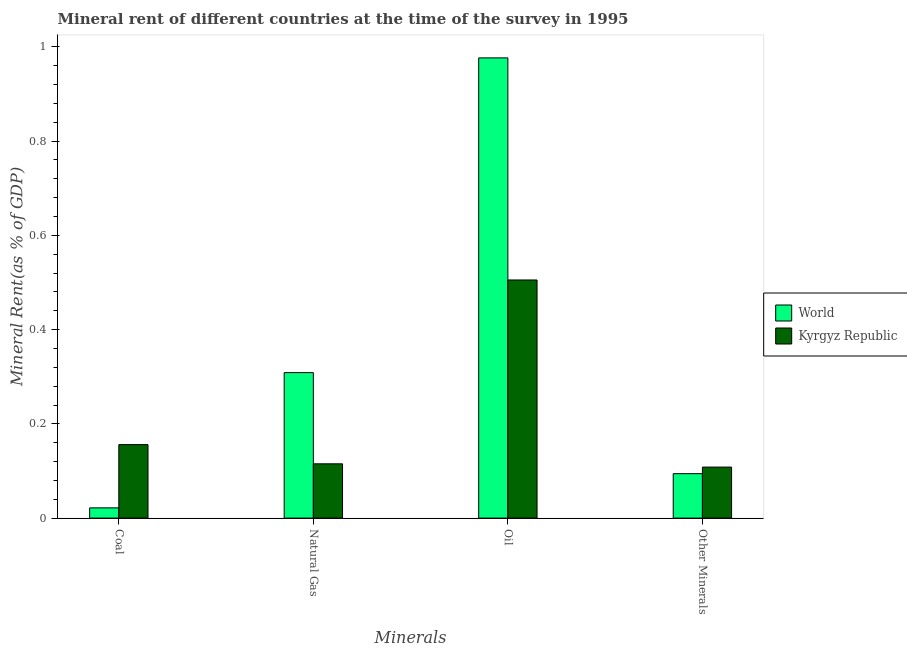How many different coloured bars are there?
Provide a succinct answer. 2. How many groups of bars are there?
Provide a succinct answer. 4. Are the number of bars per tick equal to the number of legend labels?
Make the answer very short. Yes. How many bars are there on the 3rd tick from the left?
Offer a terse response. 2. What is the label of the 1st group of bars from the left?
Provide a succinct answer. Coal. What is the  rent of other minerals in Kyrgyz Republic?
Offer a very short reply. 0.11. Across all countries, what is the maximum coal rent?
Offer a terse response. 0.16. Across all countries, what is the minimum natural gas rent?
Your response must be concise. 0.12. In which country was the coal rent maximum?
Keep it short and to the point. Kyrgyz Republic. In which country was the oil rent minimum?
Offer a very short reply. Kyrgyz Republic. What is the total natural gas rent in the graph?
Provide a short and direct response. 0.42. What is the difference between the natural gas rent in World and that in Kyrgyz Republic?
Provide a short and direct response. 0.19. What is the difference between the oil rent in Kyrgyz Republic and the  rent of other minerals in World?
Ensure brevity in your answer.  0.41. What is the average natural gas rent per country?
Provide a succinct answer. 0.21. What is the difference between the  rent of other minerals and natural gas rent in World?
Offer a very short reply. -0.21. What is the ratio of the oil rent in Kyrgyz Republic to that in World?
Your response must be concise. 0.52. What is the difference between the highest and the second highest oil rent?
Your answer should be compact. 0.47. What is the difference between the highest and the lowest natural gas rent?
Offer a terse response. 0.19. Is it the case that in every country, the sum of the coal rent and oil rent is greater than the sum of natural gas rent and  rent of other minerals?
Give a very brief answer. No. What does the 1st bar from the left in Other Minerals represents?
Offer a very short reply. World. What does the 2nd bar from the right in Coal represents?
Ensure brevity in your answer.  World. Are all the bars in the graph horizontal?
Offer a very short reply. No. What is the difference between two consecutive major ticks on the Y-axis?
Your answer should be compact. 0.2. How many legend labels are there?
Make the answer very short. 2. What is the title of the graph?
Your answer should be very brief. Mineral rent of different countries at the time of the survey in 1995. Does "Tajikistan" appear as one of the legend labels in the graph?
Offer a terse response. No. What is the label or title of the X-axis?
Provide a short and direct response. Minerals. What is the label or title of the Y-axis?
Provide a succinct answer. Mineral Rent(as % of GDP). What is the Mineral Rent(as % of GDP) of World in Coal?
Offer a very short reply. 0.02. What is the Mineral Rent(as % of GDP) of Kyrgyz Republic in Coal?
Provide a short and direct response. 0.16. What is the Mineral Rent(as % of GDP) of World in Natural Gas?
Your response must be concise. 0.31. What is the Mineral Rent(as % of GDP) of Kyrgyz Republic in Natural Gas?
Give a very brief answer. 0.12. What is the Mineral Rent(as % of GDP) in World in Oil?
Your response must be concise. 0.98. What is the Mineral Rent(as % of GDP) in Kyrgyz Republic in Oil?
Provide a succinct answer. 0.51. What is the Mineral Rent(as % of GDP) in World in Other Minerals?
Make the answer very short. 0.09. What is the Mineral Rent(as % of GDP) of Kyrgyz Republic in Other Minerals?
Your response must be concise. 0.11. Across all Minerals, what is the maximum Mineral Rent(as % of GDP) of World?
Keep it short and to the point. 0.98. Across all Minerals, what is the maximum Mineral Rent(as % of GDP) of Kyrgyz Republic?
Give a very brief answer. 0.51. Across all Minerals, what is the minimum Mineral Rent(as % of GDP) of World?
Offer a terse response. 0.02. Across all Minerals, what is the minimum Mineral Rent(as % of GDP) of Kyrgyz Republic?
Ensure brevity in your answer.  0.11. What is the total Mineral Rent(as % of GDP) in World in the graph?
Provide a succinct answer. 1.4. What is the total Mineral Rent(as % of GDP) in Kyrgyz Republic in the graph?
Your answer should be compact. 0.88. What is the difference between the Mineral Rent(as % of GDP) of World in Coal and that in Natural Gas?
Offer a terse response. -0.29. What is the difference between the Mineral Rent(as % of GDP) of Kyrgyz Republic in Coal and that in Natural Gas?
Offer a very short reply. 0.04. What is the difference between the Mineral Rent(as % of GDP) of World in Coal and that in Oil?
Provide a succinct answer. -0.95. What is the difference between the Mineral Rent(as % of GDP) of Kyrgyz Republic in Coal and that in Oil?
Your response must be concise. -0.35. What is the difference between the Mineral Rent(as % of GDP) in World in Coal and that in Other Minerals?
Your answer should be compact. -0.07. What is the difference between the Mineral Rent(as % of GDP) in Kyrgyz Republic in Coal and that in Other Minerals?
Your answer should be compact. 0.05. What is the difference between the Mineral Rent(as % of GDP) of World in Natural Gas and that in Oil?
Offer a terse response. -0.67. What is the difference between the Mineral Rent(as % of GDP) of Kyrgyz Republic in Natural Gas and that in Oil?
Keep it short and to the point. -0.39. What is the difference between the Mineral Rent(as % of GDP) of World in Natural Gas and that in Other Minerals?
Give a very brief answer. 0.21. What is the difference between the Mineral Rent(as % of GDP) of Kyrgyz Republic in Natural Gas and that in Other Minerals?
Your answer should be compact. 0.01. What is the difference between the Mineral Rent(as % of GDP) in World in Oil and that in Other Minerals?
Offer a terse response. 0.88. What is the difference between the Mineral Rent(as % of GDP) in Kyrgyz Republic in Oil and that in Other Minerals?
Offer a very short reply. 0.4. What is the difference between the Mineral Rent(as % of GDP) in World in Coal and the Mineral Rent(as % of GDP) in Kyrgyz Republic in Natural Gas?
Offer a terse response. -0.09. What is the difference between the Mineral Rent(as % of GDP) of World in Coal and the Mineral Rent(as % of GDP) of Kyrgyz Republic in Oil?
Your answer should be very brief. -0.48. What is the difference between the Mineral Rent(as % of GDP) of World in Coal and the Mineral Rent(as % of GDP) of Kyrgyz Republic in Other Minerals?
Give a very brief answer. -0.09. What is the difference between the Mineral Rent(as % of GDP) in World in Natural Gas and the Mineral Rent(as % of GDP) in Kyrgyz Republic in Oil?
Provide a succinct answer. -0.2. What is the difference between the Mineral Rent(as % of GDP) of World in Natural Gas and the Mineral Rent(as % of GDP) of Kyrgyz Republic in Other Minerals?
Your answer should be compact. 0.2. What is the difference between the Mineral Rent(as % of GDP) in World in Oil and the Mineral Rent(as % of GDP) in Kyrgyz Republic in Other Minerals?
Your answer should be compact. 0.87. What is the average Mineral Rent(as % of GDP) of World per Minerals?
Give a very brief answer. 0.35. What is the average Mineral Rent(as % of GDP) of Kyrgyz Republic per Minerals?
Your answer should be compact. 0.22. What is the difference between the Mineral Rent(as % of GDP) of World and Mineral Rent(as % of GDP) of Kyrgyz Republic in Coal?
Your response must be concise. -0.13. What is the difference between the Mineral Rent(as % of GDP) in World and Mineral Rent(as % of GDP) in Kyrgyz Republic in Natural Gas?
Your answer should be compact. 0.19. What is the difference between the Mineral Rent(as % of GDP) of World and Mineral Rent(as % of GDP) of Kyrgyz Republic in Oil?
Keep it short and to the point. 0.47. What is the difference between the Mineral Rent(as % of GDP) in World and Mineral Rent(as % of GDP) in Kyrgyz Republic in Other Minerals?
Give a very brief answer. -0.01. What is the ratio of the Mineral Rent(as % of GDP) in World in Coal to that in Natural Gas?
Your answer should be very brief. 0.07. What is the ratio of the Mineral Rent(as % of GDP) of Kyrgyz Republic in Coal to that in Natural Gas?
Make the answer very short. 1.35. What is the ratio of the Mineral Rent(as % of GDP) in World in Coal to that in Oil?
Your response must be concise. 0.02. What is the ratio of the Mineral Rent(as % of GDP) of Kyrgyz Republic in Coal to that in Oil?
Your response must be concise. 0.31. What is the ratio of the Mineral Rent(as % of GDP) in World in Coal to that in Other Minerals?
Keep it short and to the point. 0.23. What is the ratio of the Mineral Rent(as % of GDP) of Kyrgyz Republic in Coal to that in Other Minerals?
Your answer should be compact. 1.44. What is the ratio of the Mineral Rent(as % of GDP) of World in Natural Gas to that in Oil?
Your answer should be very brief. 0.32. What is the ratio of the Mineral Rent(as % of GDP) in Kyrgyz Republic in Natural Gas to that in Oil?
Give a very brief answer. 0.23. What is the ratio of the Mineral Rent(as % of GDP) of World in Natural Gas to that in Other Minerals?
Make the answer very short. 3.27. What is the ratio of the Mineral Rent(as % of GDP) in Kyrgyz Republic in Natural Gas to that in Other Minerals?
Provide a succinct answer. 1.06. What is the ratio of the Mineral Rent(as % of GDP) in World in Oil to that in Other Minerals?
Your response must be concise. 10.35. What is the ratio of the Mineral Rent(as % of GDP) of Kyrgyz Republic in Oil to that in Other Minerals?
Your response must be concise. 4.67. What is the difference between the highest and the second highest Mineral Rent(as % of GDP) of World?
Your answer should be compact. 0.67. What is the difference between the highest and the second highest Mineral Rent(as % of GDP) in Kyrgyz Republic?
Ensure brevity in your answer.  0.35. What is the difference between the highest and the lowest Mineral Rent(as % of GDP) of World?
Provide a short and direct response. 0.95. What is the difference between the highest and the lowest Mineral Rent(as % of GDP) of Kyrgyz Republic?
Your answer should be compact. 0.4. 